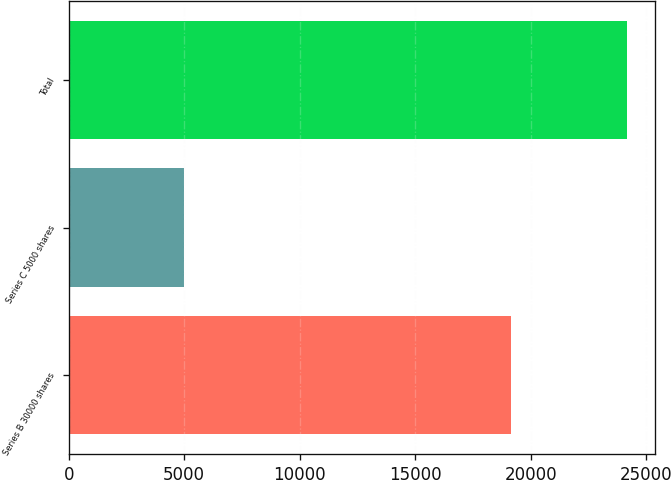<chart> <loc_0><loc_0><loc_500><loc_500><bar_chart><fcel>Series B 30000 shares<fcel>Series C 5000 shares<fcel>Total<nl><fcel>19160<fcel>5000<fcel>24160<nl></chart> 